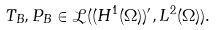Convert formula to latex. <formula><loc_0><loc_0><loc_500><loc_500>T _ { B } , P _ { B } \in \mathcal { L } ( ( H ^ { 1 } ( \Omega ) ) ^ { \prime } , L ^ { 2 } ( \Omega ) ) .</formula> 